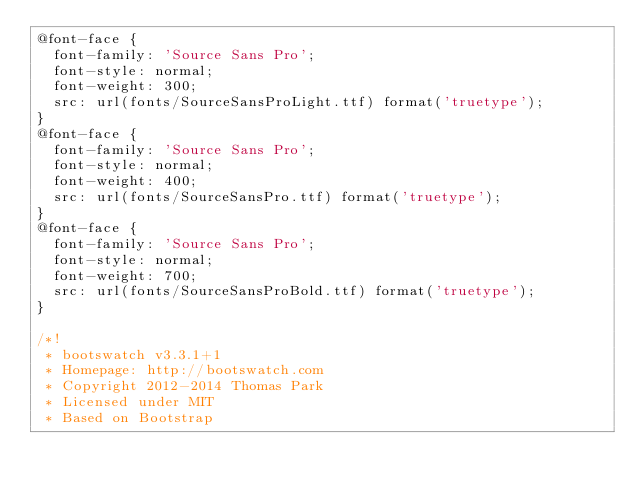<code> <loc_0><loc_0><loc_500><loc_500><_CSS_>@font-face {
  font-family: 'Source Sans Pro';
  font-style: normal;
  font-weight: 300;
  src: url(fonts/SourceSansProLight.ttf) format('truetype');
}
@font-face {
  font-family: 'Source Sans Pro';
  font-style: normal;
  font-weight: 400;
  src: url(fonts/SourceSansPro.ttf) format('truetype');
}
@font-face {
  font-family: 'Source Sans Pro';
  font-style: normal;
  font-weight: 700;
  src: url(fonts/SourceSansProBold.ttf) format('truetype');
}

/*!
 * bootswatch v3.3.1+1
 * Homepage: http://bootswatch.com
 * Copyright 2012-2014 Thomas Park
 * Licensed under MIT
 * Based on Bootstrap</code> 